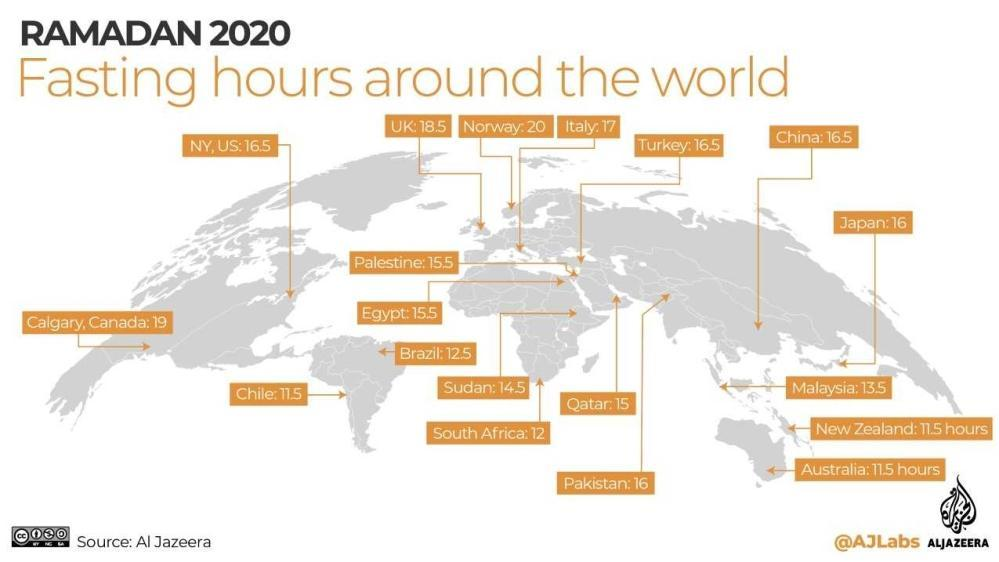Which country has the longest fasting hours around the world for Ramadan 2020?
Answer the question with a short phrase. Norway What is the fasting hours in Qatar for Ramadan 2020? 15 What is the fasting hours in Malaysia for Ramadan 2020? 13.5 